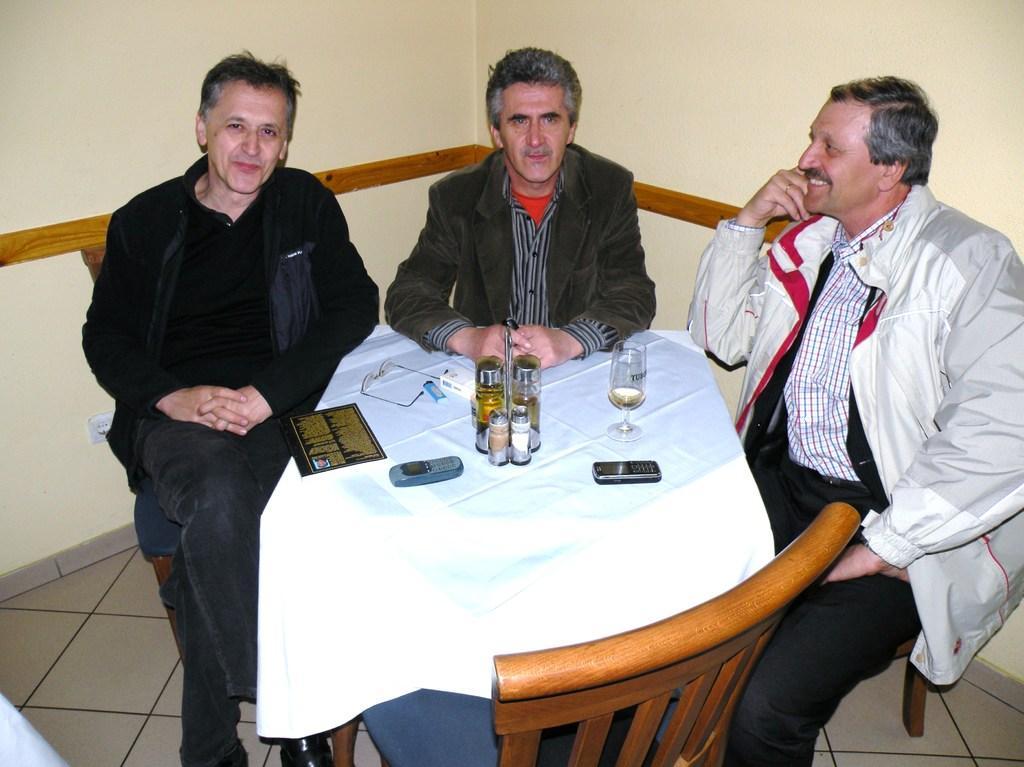Describe this image in one or two sentences. This picture is of inside the room. On the right there is a man wearing white color jacket, smiling and sitting on the chair. In the center there is a man sitting on the chair. On the left there is a man wearing black color t-shirt, smiling and sitting on the chair. In the center there is a table on the top of which glass, bottles, spectacles, card and mobile phones are placed. In the foreground there is a chair and the background there is a wall. 